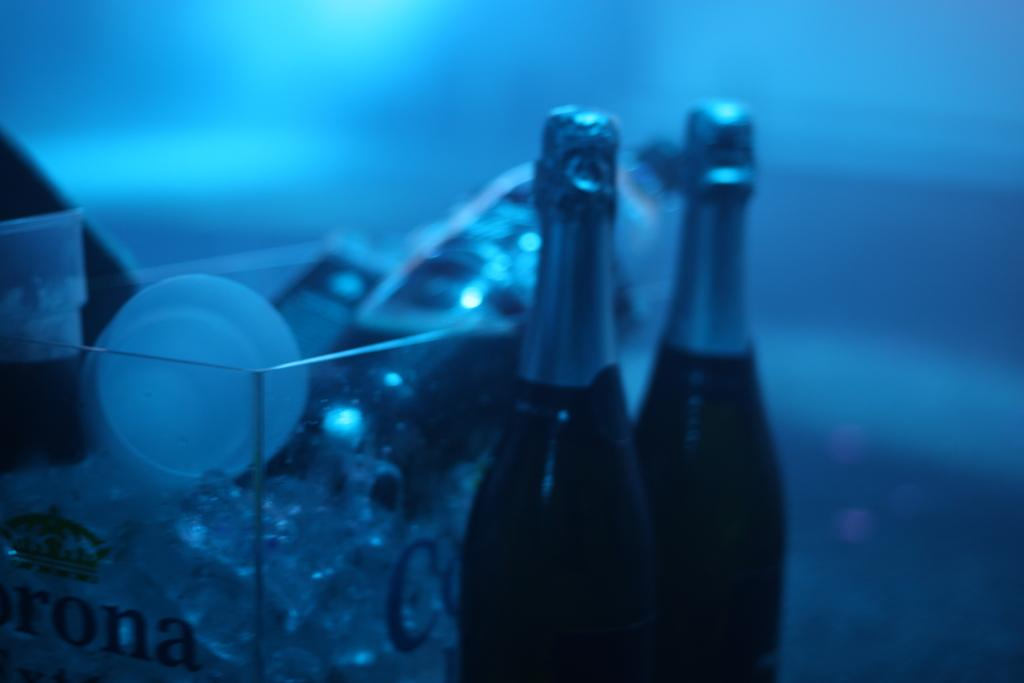<image>
Write a terse but informative summary of the picture. Two black bottles near Corona box with ice 